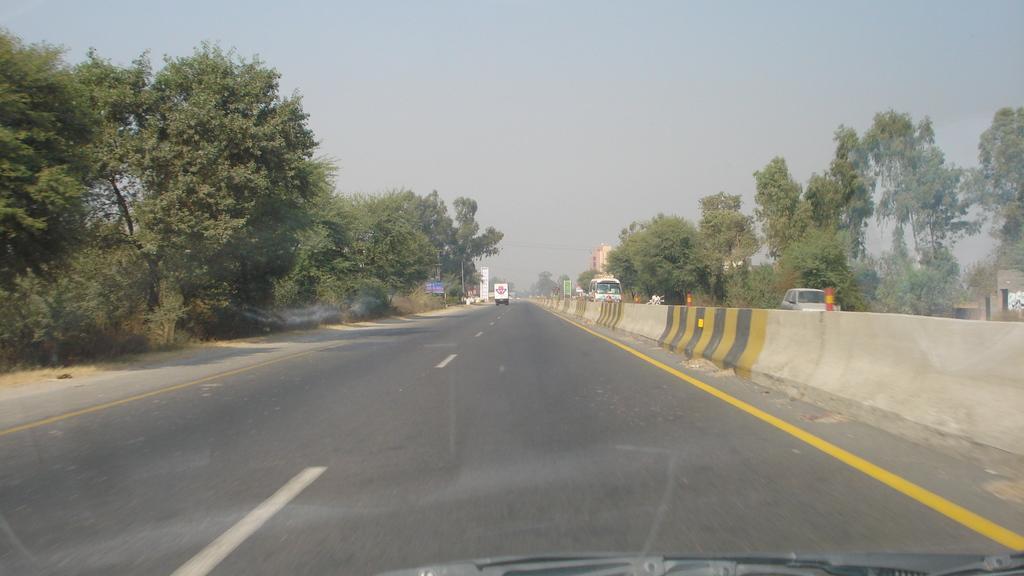Could you give a brief overview of what you see in this image? In this Image I see the road, divider, view vehicles over here, trees, buildings and the sky and I can also see a wiper over here. 